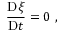Convert formula to latex. <formula><loc_0><loc_0><loc_500><loc_500>\frac { D \xi } { D t } = 0 \ ,</formula> 